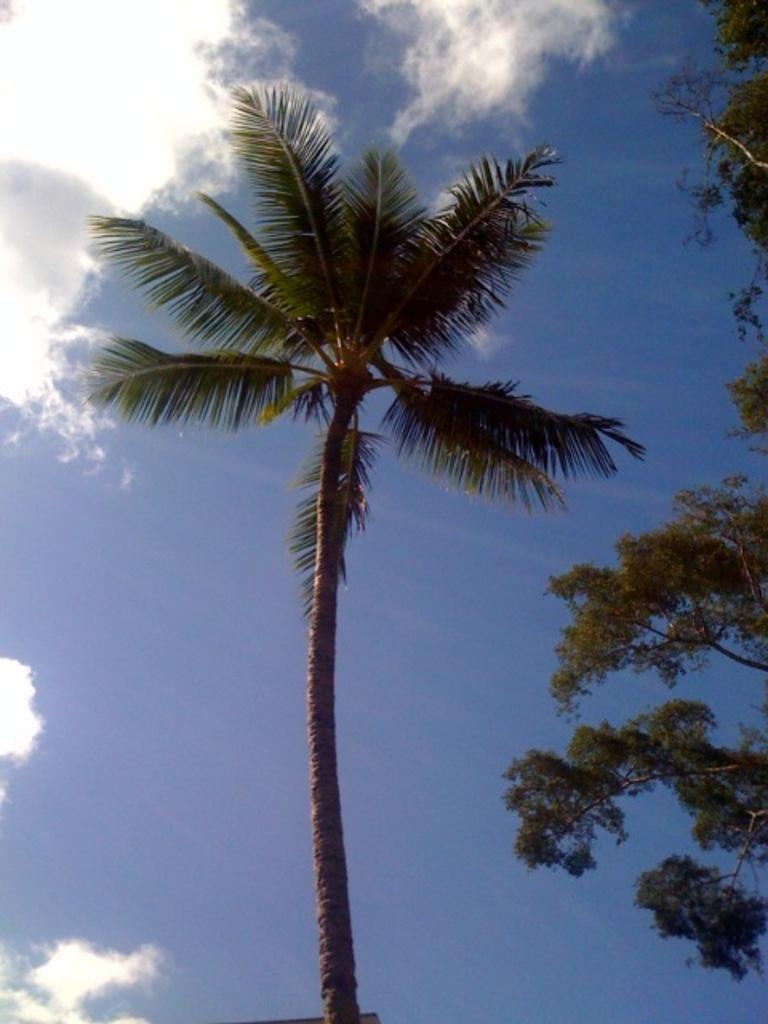What type of tree is located in the middle of the image? There is a coconut tree in the middle of the image. What other trees can be seen in the image? There are trees on the right side of the image. What is visible in the background of the image? The sky is visible in the background of the image. What can be observed in the sky in the image? Clouds are present in the background of the image. What substance is being spread by the trees in the image? There is no substance being spread by the trees in the image; the trees are simply standing in their natural state. 